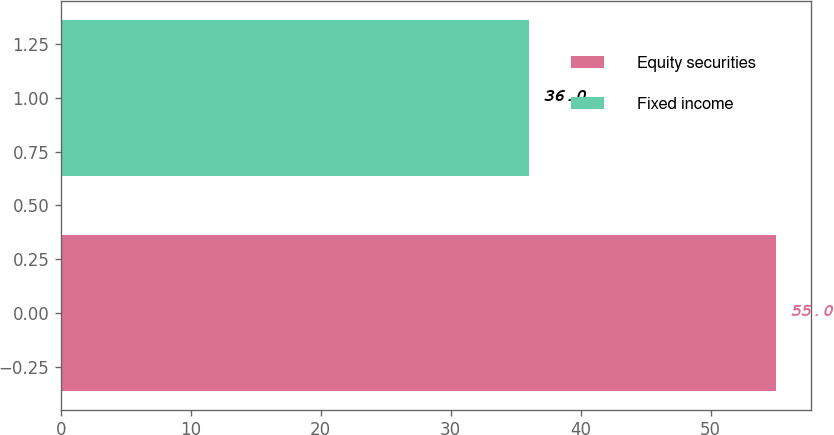<chart> <loc_0><loc_0><loc_500><loc_500><bar_chart><fcel>Equity securities<fcel>Fixed income<nl><fcel>55<fcel>36<nl></chart> 